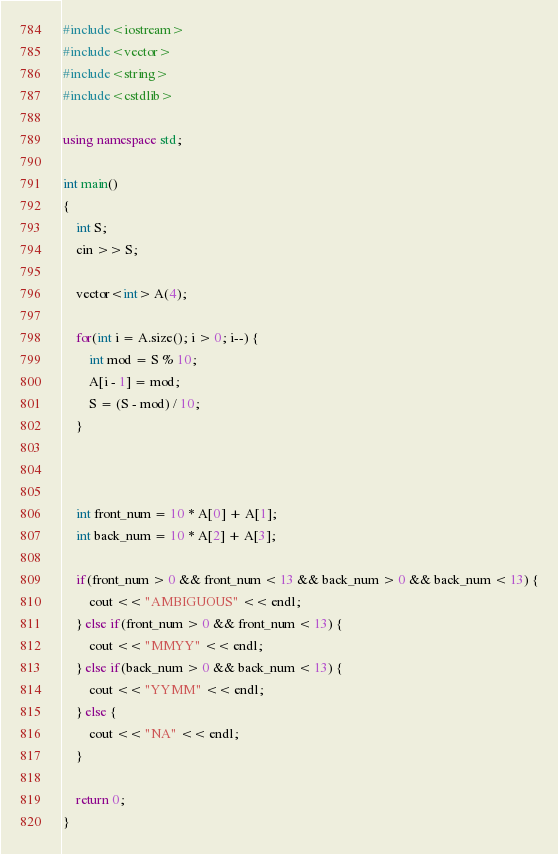<code> <loc_0><loc_0><loc_500><loc_500><_C++_>#include<iostream>
#include<vector>
#include<string>
#include<cstdlib>

using namespace std;

int main()
{
    int S;
    cin >> S;

    vector<int> A(4);

    for(int i = A.size(); i > 0; i--) {
        int mod = S % 10;
        A[i - 1] = mod;
        S = (S - mod) / 10;
    }



    int front_num = 10 * A[0] + A[1];
    int back_num = 10 * A[2] + A[3];

    if(front_num > 0 && front_num < 13 && back_num > 0 && back_num < 13) {
        cout << "AMBIGUOUS" << endl;
    } else if(front_num > 0 && front_num < 13) {
        cout << "MMYY" << endl;
    } else if(back_num > 0 && back_num < 13) {
        cout << "YYMM" << endl;
    } else {
        cout << "NA" << endl;
    }

    return 0;
}</code> 